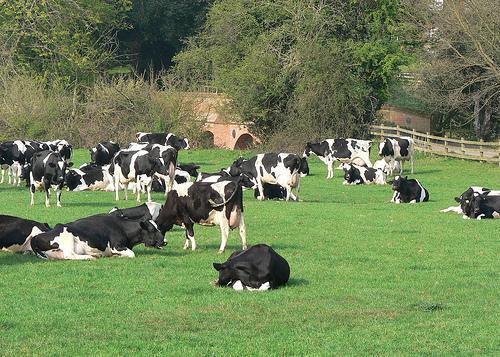How many black cows are sitting in the center-front of the image?
Give a very brief answer. 1. 